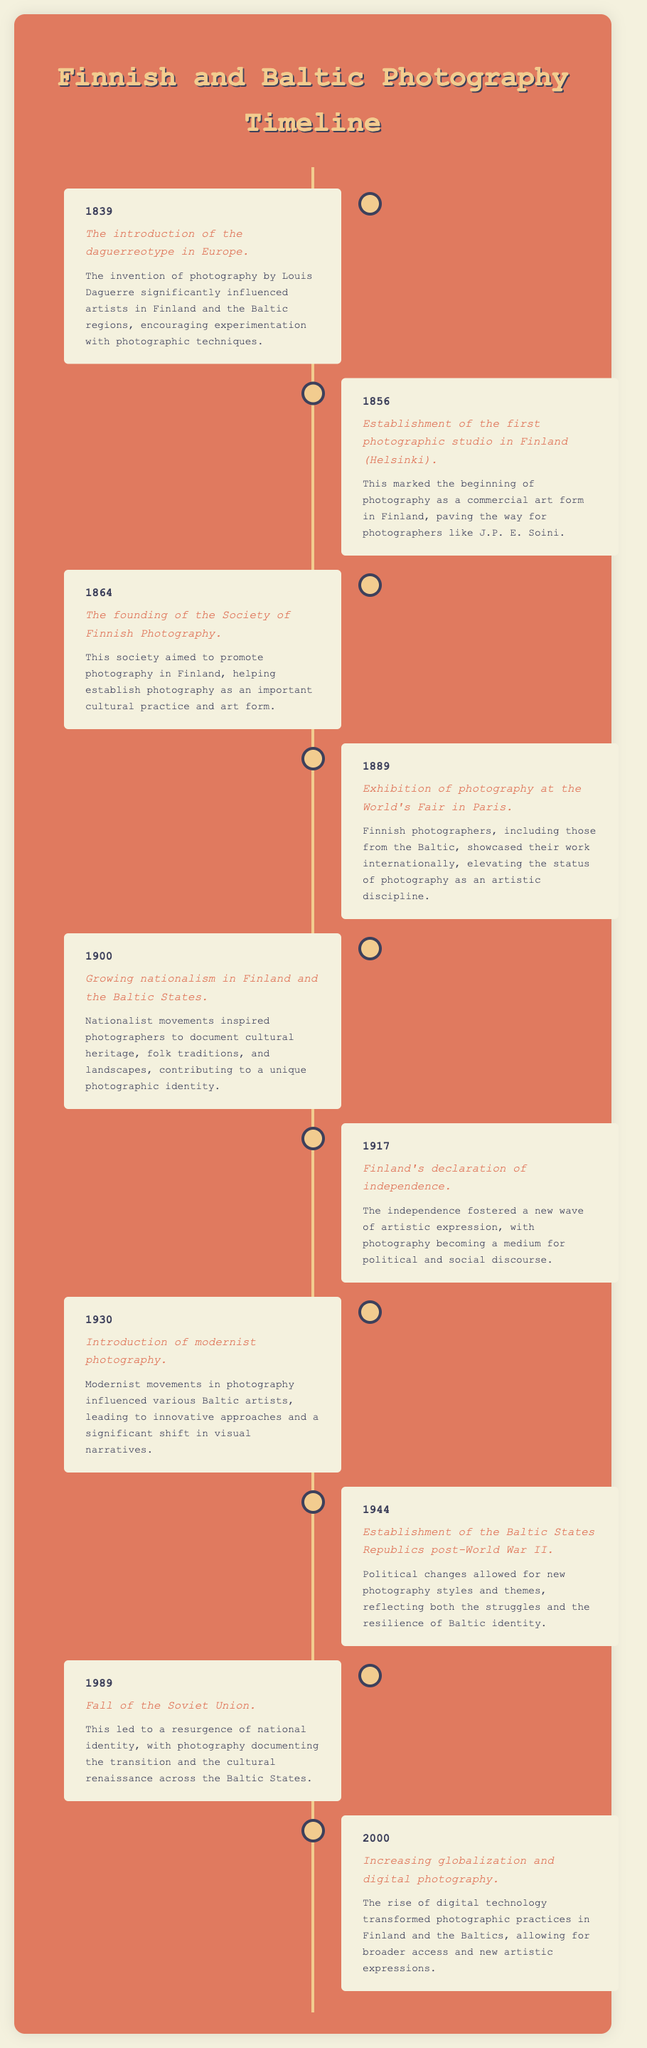What year was the first photographic studio established in Finland? The document mentions the year 1856 as the establishment of the first photographic studio in Helsinki.
Answer: 1856 Who invented the daguerreotype? The document states that the invention of photography by Louis Daguerre introduced the daguerreotype in Europe.
Answer: Louis Daguerre What significant event occurred in Finland in 1917? The timeline notes that Finland declared independence in 1917, marking a critical moment in its history.
Answer: Declaration of independence Which year marked the introduction of modernist photography? According to the document, the introduction of modernist photography took place in 1930.
Answer: 1930 What was a major influence on photography in the Baltic States post-World War II? The establishment of the Baltic States Republics after World War II allowed for new photography styles reflecting struggles and resilience.
Answer: Political changes Which exhibition showcased Finnish photographers internationally in 1889? The document refers to the exhibition of photography at the World's Fair in Paris in 1889, where Finnish photographers showcased their work.
Answer: World's Fair in Paris How did the fall of the Soviet Union in 1989 affect national identity? The document notes that the fall of the Soviet Union led to a resurgence of national identity, documented through photography in the Baltic States.
Answer: Resurgence of national identity What significant technological change occurred in 2000? The timeline indicates that increasing globalization and digital photography transformed photographic practices in Finland and the Baltics.
Answer: Digital photography 